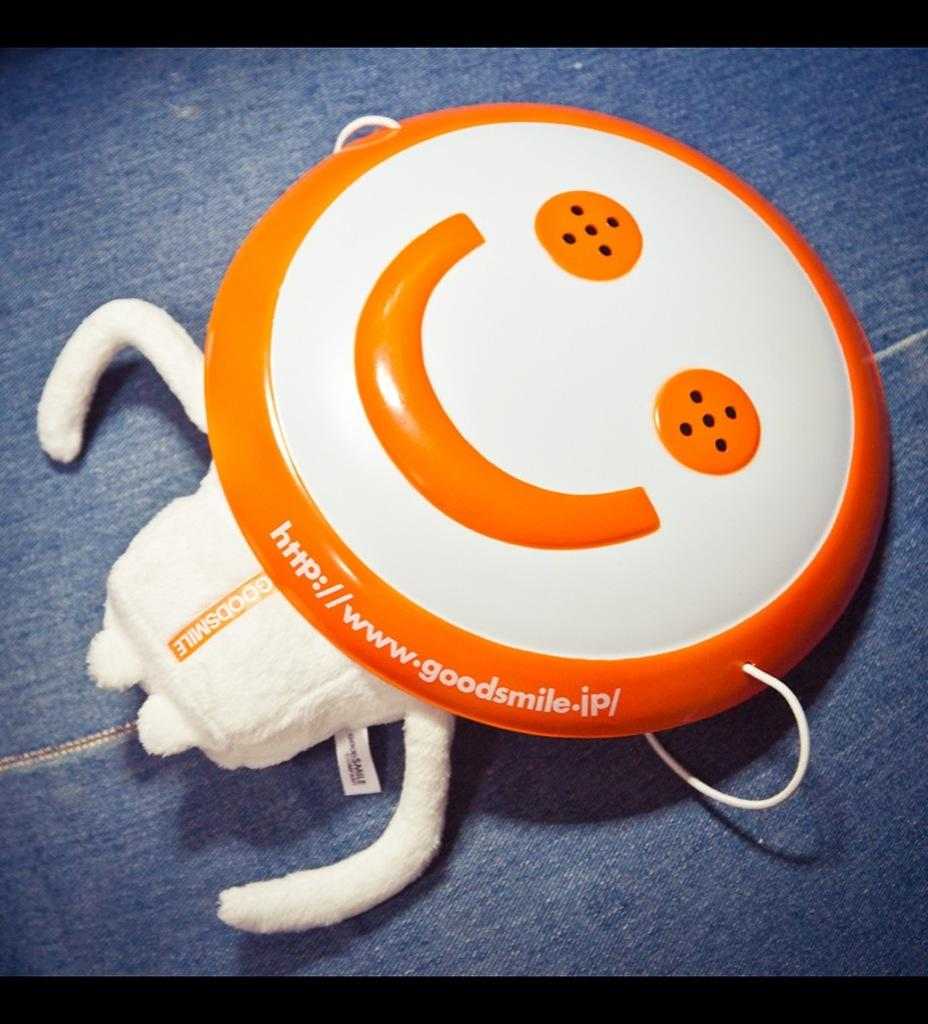What is attached to the toy in the image? There is a smiley emoji badge tied to the toy in the image. Where are the toy and badge located? The toy and badge are on a platform in the image. What type of cracker is being used as a hat for the toy in the image? There is no cracker or hat present in the image; it features a toy with a smiley emoji badge on a platform. 